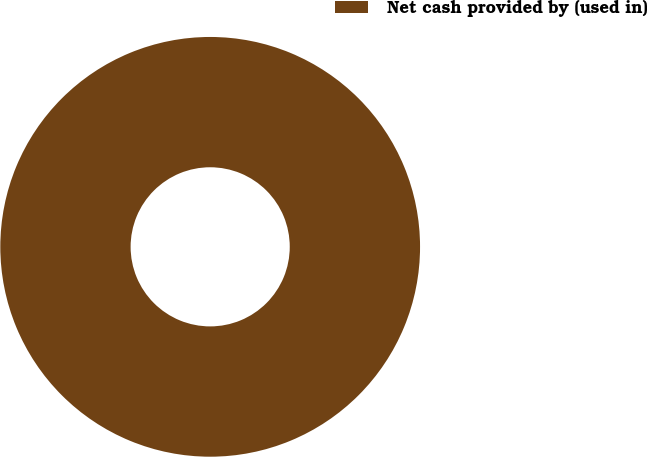Convert chart to OTSL. <chart><loc_0><loc_0><loc_500><loc_500><pie_chart><fcel>Net cash provided by (used in)<nl><fcel>100.0%<nl></chart> 